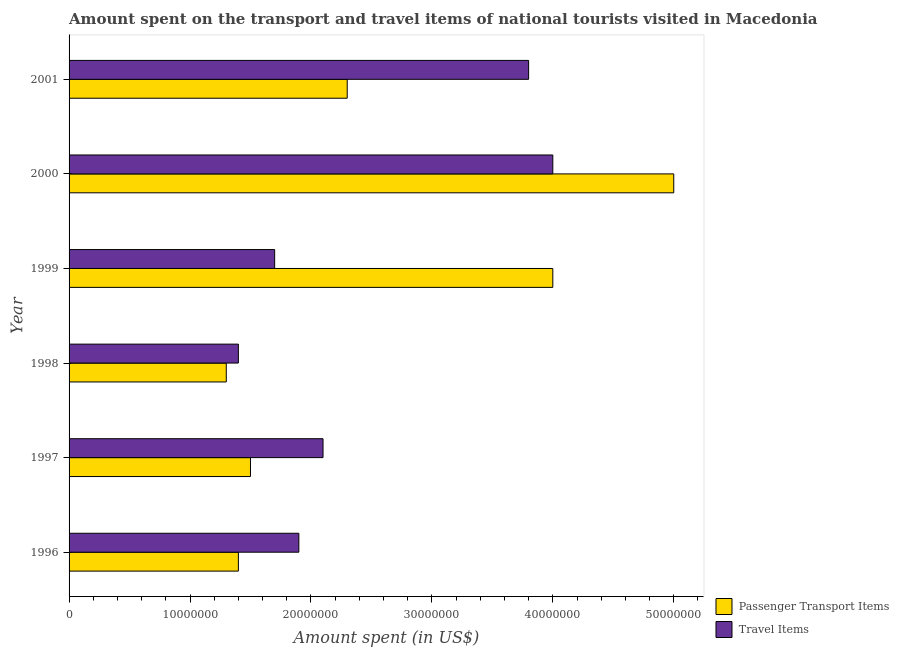How many groups of bars are there?
Ensure brevity in your answer.  6. What is the label of the 1st group of bars from the top?
Your answer should be compact. 2001. What is the amount spent on passenger transport items in 1997?
Keep it short and to the point. 1.50e+07. Across all years, what is the maximum amount spent in travel items?
Offer a very short reply. 4.00e+07. Across all years, what is the minimum amount spent in travel items?
Make the answer very short. 1.40e+07. In which year was the amount spent in travel items maximum?
Offer a terse response. 2000. What is the total amount spent on passenger transport items in the graph?
Provide a short and direct response. 1.55e+08. What is the difference between the amount spent on passenger transport items in 1996 and that in 2001?
Make the answer very short. -9.00e+06. What is the difference between the amount spent on passenger transport items in 1998 and the amount spent in travel items in 2001?
Your answer should be very brief. -2.50e+07. What is the average amount spent on passenger transport items per year?
Offer a very short reply. 2.58e+07. In the year 2000, what is the difference between the amount spent on passenger transport items and amount spent in travel items?
Keep it short and to the point. 1.00e+07. In how many years, is the amount spent on passenger transport items greater than 8000000 US$?
Your answer should be compact. 6. What is the ratio of the amount spent in travel items in 1997 to that in 2000?
Offer a terse response. 0.53. What is the difference between the highest and the second highest amount spent on passenger transport items?
Provide a short and direct response. 1.00e+07. What is the difference between the highest and the lowest amount spent on passenger transport items?
Your response must be concise. 3.70e+07. In how many years, is the amount spent on passenger transport items greater than the average amount spent on passenger transport items taken over all years?
Provide a short and direct response. 2. What does the 1st bar from the top in 1997 represents?
Offer a very short reply. Travel Items. What does the 2nd bar from the bottom in 1997 represents?
Provide a short and direct response. Travel Items. Are all the bars in the graph horizontal?
Your response must be concise. Yes. Are the values on the major ticks of X-axis written in scientific E-notation?
Your answer should be very brief. No. Does the graph contain grids?
Give a very brief answer. No. What is the title of the graph?
Provide a short and direct response. Amount spent on the transport and travel items of national tourists visited in Macedonia. What is the label or title of the X-axis?
Provide a succinct answer. Amount spent (in US$). What is the Amount spent (in US$) in Passenger Transport Items in 1996?
Offer a terse response. 1.40e+07. What is the Amount spent (in US$) of Travel Items in 1996?
Your answer should be compact. 1.90e+07. What is the Amount spent (in US$) of Passenger Transport Items in 1997?
Make the answer very short. 1.50e+07. What is the Amount spent (in US$) in Travel Items in 1997?
Ensure brevity in your answer.  2.10e+07. What is the Amount spent (in US$) in Passenger Transport Items in 1998?
Offer a terse response. 1.30e+07. What is the Amount spent (in US$) in Travel Items in 1998?
Keep it short and to the point. 1.40e+07. What is the Amount spent (in US$) in Passenger Transport Items in 1999?
Your answer should be compact. 4.00e+07. What is the Amount spent (in US$) in Travel Items in 1999?
Ensure brevity in your answer.  1.70e+07. What is the Amount spent (in US$) in Passenger Transport Items in 2000?
Provide a short and direct response. 5.00e+07. What is the Amount spent (in US$) in Travel Items in 2000?
Give a very brief answer. 4.00e+07. What is the Amount spent (in US$) of Passenger Transport Items in 2001?
Provide a succinct answer. 2.30e+07. What is the Amount spent (in US$) in Travel Items in 2001?
Give a very brief answer. 3.80e+07. Across all years, what is the maximum Amount spent (in US$) of Travel Items?
Provide a short and direct response. 4.00e+07. Across all years, what is the minimum Amount spent (in US$) of Passenger Transport Items?
Make the answer very short. 1.30e+07. Across all years, what is the minimum Amount spent (in US$) in Travel Items?
Provide a succinct answer. 1.40e+07. What is the total Amount spent (in US$) in Passenger Transport Items in the graph?
Give a very brief answer. 1.55e+08. What is the total Amount spent (in US$) of Travel Items in the graph?
Keep it short and to the point. 1.49e+08. What is the difference between the Amount spent (in US$) of Passenger Transport Items in 1996 and that in 1999?
Your answer should be very brief. -2.60e+07. What is the difference between the Amount spent (in US$) of Travel Items in 1996 and that in 1999?
Your answer should be very brief. 2.00e+06. What is the difference between the Amount spent (in US$) of Passenger Transport Items in 1996 and that in 2000?
Your answer should be very brief. -3.60e+07. What is the difference between the Amount spent (in US$) of Travel Items in 1996 and that in 2000?
Your response must be concise. -2.10e+07. What is the difference between the Amount spent (in US$) in Passenger Transport Items in 1996 and that in 2001?
Ensure brevity in your answer.  -9.00e+06. What is the difference between the Amount spent (in US$) in Travel Items in 1996 and that in 2001?
Provide a succinct answer. -1.90e+07. What is the difference between the Amount spent (in US$) of Passenger Transport Items in 1997 and that in 1999?
Keep it short and to the point. -2.50e+07. What is the difference between the Amount spent (in US$) in Passenger Transport Items in 1997 and that in 2000?
Your response must be concise. -3.50e+07. What is the difference between the Amount spent (in US$) of Travel Items in 1997 and that in 2000?
Your response must be concise. -1.90e+07. What is the difference between the Amount spent (in US$) in Passenger Transport Items in 1997 and that in 2001?
Keep it short and to the point. -8.00e+06. What is the difference between the Amount spent (in US$) of Travel Items in 1997 and that in 2001?
Provide a short and direct response. -1.70e+07. What is the difference between the Amount spent (in US$) in Passenger Transport Items in 1998 and that in 1999?
Your answer should be very brief. -2.70e+07. What is the difference between the Amount spent (in US$) of Travel Items in 1998 and that in 1999?
Provide a short and direct response. -3.00e+06. What is the difference between the Amount spent (in US$) of Passenger Transport Items in 1998 and that in 2000?
Make the answer very short. -3.70e+07. What is the difference between the Amount spent (in US$) in Travel Items in 1998 and that in 2000?
Your response must be concise. -2.60e+07. What is the difference between the Amount spent (in US$) in Passenger Transport Items in 1998 and that in 2001?
Your answer should be compact. -1.00e+07. What is the difference between the Amount spent (in US$) in Travel Items in 1998 and that in 2001?
Offer a terse response. -2.40e+07. What is the difference between the Amount spent (in US$) of Passenger Transport Items in 1999 and that in 2000?
Offer a very short reply. -1.00e+07. What is the difference between the Amount spent (in US$) of Travel Items in 1999 and that in 2000?
Keep it short and to the point. -2.30e+07. What is the difference between the Amount spent (in US$) in Passenger Transport Items in 1999 and that in 2001?
Make the answer very short. 1.70e+07. What is the difference between the Amount spent (in US$) in Travel Items in 1999 and that in 2001?
Keep it short and to the point. -2.10e+07. What is the difference between the Amount spent (in US$) of Passenger Transport Items in 2000 and that in 2001?
Offer a terse response. 2.70e+07. What is the difference between the Amount spent (in US$) in Passenger Transport Items in 1996 and the Amount spent (in US$) in Travel Items in 1997?
Provide a succinct answer. -7.00e+06. What is the difference between the Amount spent (in US$) in Passenger Transport Items in 1996 and the Amount spent (in US$) in Travel Items in 1999?
Keep it short and to the point. -3.00e+06. What is the difference between the Amount spent (in US$) in Passenger Transport Items in 1996 and the Amount spent (in US$) in Travel Items in 2000?
Your answer should be compact. -2.60e+07. What is the difference between the Amount spent (in US$) of Passenger Transport Items in 1996 and the Amount spent (in US$) of Travel Items in 2001?
Provide a short and direct response. -2.40e+07. What is the difference between the Amount spent (in US$) in Passenger Transport Items in 1997 and the Amount spent (in US$) in Travel Items in 2000?
Keep it short and to the point. -2.50e+07. What is the difference between the Amount spent (in US$) in Passenger Transport Items in 1997 and the Amount spent (in US$) in Travel Items in 2001?
Provide a short and direct response. -2.30e+07. What is the difference between the Amount spent (in US$) of Passenger Transport Items in 1998 and the Amount spent (in US$) of Travel Items in 2000?
Offer a very short reply. -2.70e+07. What is the difference between the Amount spent (in US$) of Passenger Transport Items in 1998 and the Amount spent (in US$) of Travel Items in 2001?
Offer a terse response. -2.50e+07. What is the average Amount spent (in US$) in Passenger Transport Items per year?
Ensure brevity in your answer.  2.58e+07. What is the average Amount spent (in US$) of Travel Items per year?
Ensure brevity in your answer.  2.48e+07. In the year 1996, what is the difference between the Amount spent (in US$) of Passenger Transport Items and Amount spent (in US$) of Travel Items?
Your response must be concise. -5.00e+06. In the year 1997, what is the difference between the Amount spent (in US$) in Passenger Transport Items and Amount spent (in US$) in Travel Items?
Keep it short and to the point. -6.00e+06. In the year 1999, what is the difference between the Amount spent (in US$) of Passenger Transport Items and Amount spent (in US$) of Travel Items?
Your response must be concise. 2.30e+07. In the year 2001, what is the difference between the Amount spent (in US$) in Passenger Transport Items and Amount spent (in US$) in Travel Items?
Make the answer very short. -1.50e+07. What is the ratio of the Amount spent (in US$) of Passenger Transport Items in 1996 to that in 1997?
Your answer should be compact. 0.93. What is the ratio of the Amount spent (in US$) of Travel Items in 1996 to that in 1997?
Offer a terse response. 0.9. What is the ratio of the Amount spent (in US$) of Travel Items in 1996 to that in 1998?
Offer a terse response. 1.36. What is the ratio of the Amount spent (in US$) of Travel Items in 1996 to that in 1999?
Your answer should be very brief. 1.12. What is the ratio of the Amount spent (in US$) in Passenger Transport Items in 1996 to that in 2000?
Your response must be concise. 0.28. What is the ratio of the Amount spent (in US$) in Travel Items in 1996 to that in 2000?
Offer a terse response. 0.47. What is the ratio of the Amount spent (in US$) of Passenger Transport Items in 1996 to that in 2001?
Make the answer very short. 0.61. What is the ratio of the Amount spent (in US$) in Travel Items in 1996 to that in 2001?
Offer a terse response. 0.5. What is the ratio of the Amount spent (in US$) of Passenger Transport Items in 1997 to that in 1998?
Your answer should be compact. 1.15. What is the ratio of the Amount spent (in US$) of Travel Items in 1997 to that in 1998?
Offer a very short reply. 1.5. What is the ratio of the Amount spent (in US$) of Travel Items in 1997 to that in 1999?
Ensure brevity in your answer.  1.24. What is the ratio of the Amount spent (in US$) of Passenger Transport Items in 1997 to that in 2000?
Keep it short and to the point. 0.3. What is the ratio of the Amount spent (in US$) of Travel Items in 1997 to that in 2000?
Your response must be concise. 0.53. What is the ratio of the Amount spent (in US$) in Passenger Transport Items in 1997 to that in 2001?
Your answer should be compact. 0.65. What is the ratio of the Amount spent (in US$) of Travel Items in 1997 to that in 2001?
Provide a short and direct response. 0.55. What is the ratio of the Amount spent (in US$) of Passenger Transport Items in 1998 to that in 1999?
Offer a very short reply. 0.33. What is the ratio of the Amount spent (in US$) of Travel Items in 1998 to that in 1999?
Your answer should be compact. 0.82. What is the ratio of the Amount spent (in US$) of Passenger Transport Items in 1998 to that in 2000?
Your response must be concise. 0.26. What is the ratio of the Amount spent (in US$) in Passenger Transport Items in 1998 to that in 2001?
Give a very brief answer. 0.57. What is the ratio of the Amount spent (in US$) of Travel Items in 1998 to that in 2001?
Ensure brevity in your answer.  0.37. What is the ratio of the Amount spent (in US$) of Travel Items in 1999 to that in 2000?
Ensure brevity in your answer.  0.42. What is the ratio of the Amount spent (in US$) of Passenger Transport Items in 1999 to that in 2001?
Offer a very short reply. 1.74. What is the ratio of the Amount spent (in US$) in Travel Items in 1999 to that in 2001?
Provide a short and direct response. 0.45. What is the ratio of the Amount spent (in US$) in Passenger Transport Items in 2000 to that in 2001?
Your answer should be very brief. 2.17. What is the ratio of the Amount spent (in US$) in Travel Items in 2000 to that in 2001?
Keep it short and to the point. 1.05. What is the difference between the highest and the second highest Amount spent (in US$) in Passenger Transport Items?
Ensure brevity in your answer.  1.00e+07. What is the difference between the highest and the lowest Amount spent (in US$) in Passenger Transport Items?
Offer a very short reply. 3.70e+07. What is the difference between the highest and the lowest Amount spent (in US$) in Travel Items?
Offer a very short reply. 2.60e+07. 